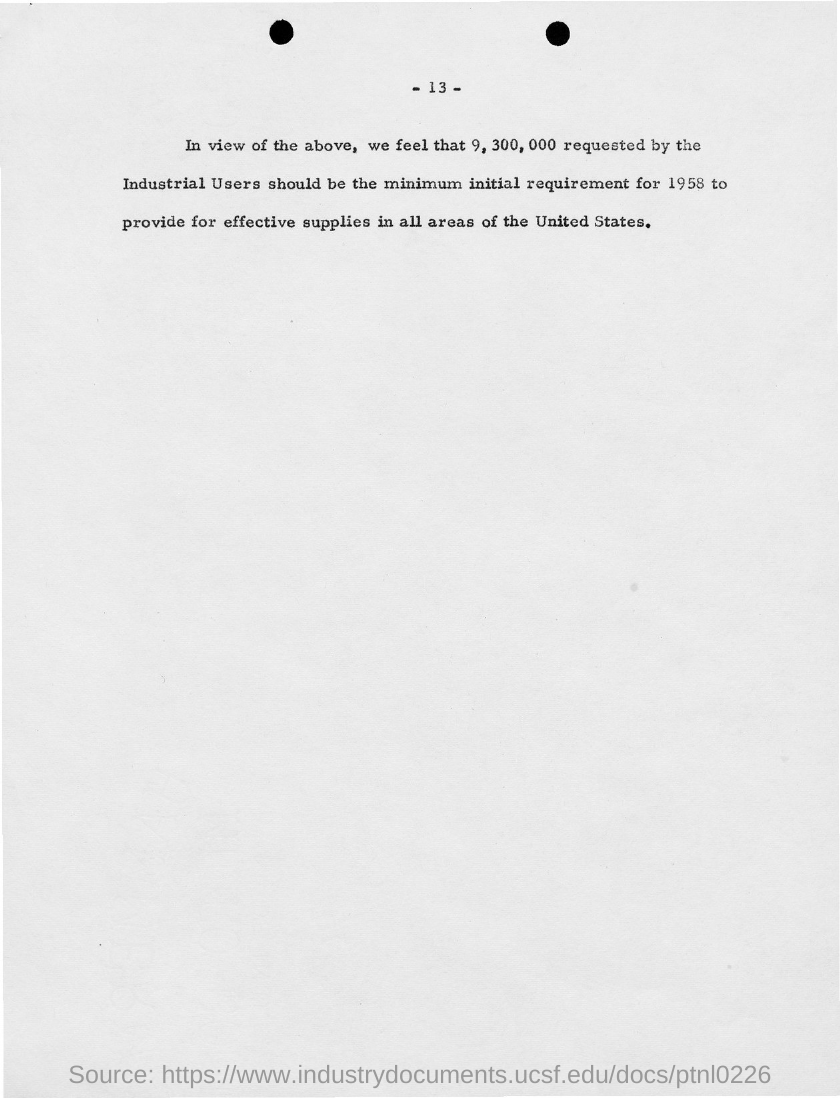What is the page no mentioned in this document?
Your response must be concise. 13. 